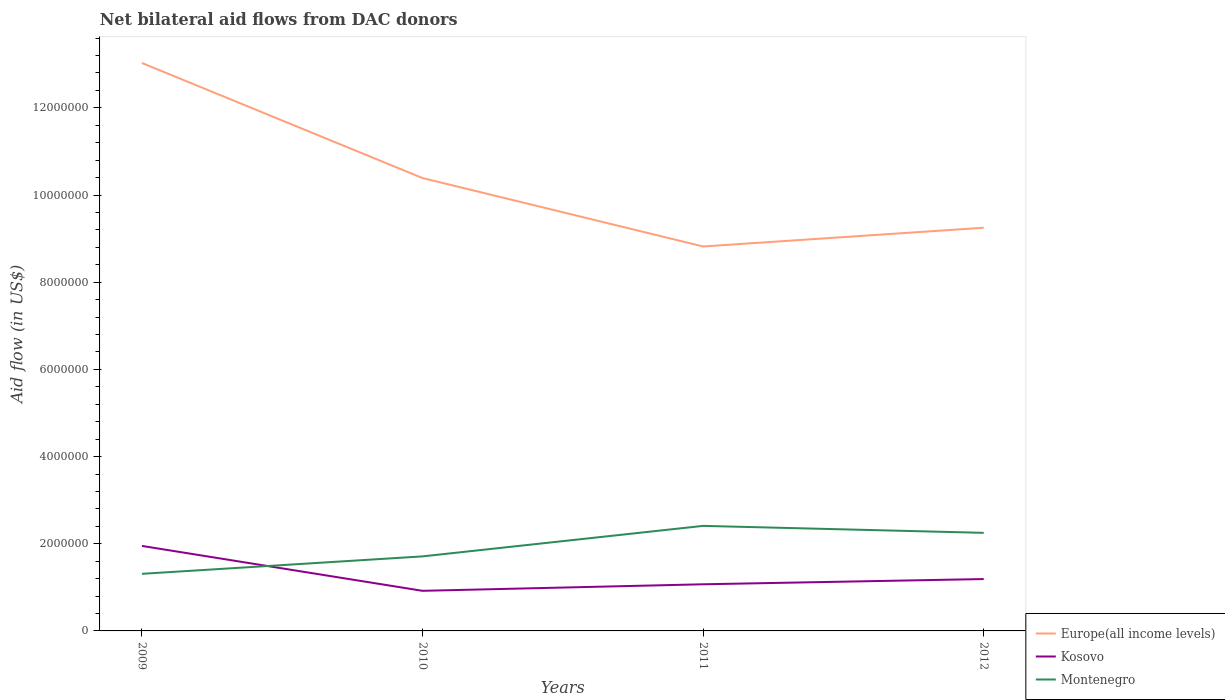Is the number of lines equal to the number of legend labels?
Keep it short and to the point. Yes. Across all years, what is the maximum net bilateral aid flow in Europe(all income levels)?
Give a very brief answer. 8.82e+06. In which year was the net bilateral aid flow in Europe(all income levels) maximum?
Your answer should be very brief. 2011. What is the total net bilateral aid flow in Kosovo in the graph?
Make the answer very short. 8.80e+05. What is the difference between the highest and the second highest net bilateral aid flow in Montenegro?
Offer a very short reply. 1.10e+06. Is the net bilateral aid flow in Kosovo strictly greater than the net bilateral aid flow in Europe(all income levels) over the years?
Your response must be concise. Yes. How many lines are there?
Your answer should be compact. 3. What is the difference between two consecutive major ticks on the Y-axis?
Ensure brevity in your answer.  2.00e+06. Are the values on the major ticks of Y-axis written in scientific E-notation?
Provide a short and direct response. No. Where does the legend appear in the graph?
Offer a very short reply. Bottom right. What is the title of the graph?
Your response must be concise. Net bilateral aid flows from DAC donors. Does "Thailand" appear as one of the legend labels in the graph?
Provide a short and direct response. No. What is the label or title of the X-axis?
Your answer should be very brief. Years. What is the label or title of the Y-axis?
Provide a short and direct response. Aid flow (in US$). What is the Aid flow (in US$) in Europe(all income levels) in 2009?
Offer a terse response. 1.30e+07. What is the Aid flow (in US$) in Kosovo in 2009?
Provide a short and direct response. 1.95e+06. What is the Aid flow (in US$) of Montenegro in 2009?
Ensure brevity in your answer.  1.31e+06. What is the Aid flow (in US$) of Europe(all income levels) in 2010?
Offer a terse response. 1.04e+07. What is the Aid flow (in US$) of Kosovo in 2010?
Your answer should be compact. 9.20e+05. What is the Aid flow (in US$) of Montenegro in 2010?
Your response must be concise. 1.71e+06. What is the Aid flow (in US$) of Europe(all income levels) in 2011?
Provide a succinct answer. 8.82e+06. What is the Aid flow (in US$) in Kosovo in 2011?
Keep it short and to the point. 1.07e+06. What is the Aid flow (in US$) of Montenegro in 2011?
Ensure brevity in your answer.  2.41e+06. What is the Aid flow (in US$) of Europe(all income levels) in 2012?
Ensure brevity in your answer.  9.25e+06. What is the Aid flow (in US$) in Kosovo in 2012?
Your answer should be very brief. 1.19e+06. What is the Aid flow (in US$) of Montenegro in 2012?
Provide a succinct answer. 2.25e+06. Across all years, what is the maximum Aid flow (in US$) of Europe(all income levels)?
Your response must be concise. 1.30e+07. Across all years, what is the maximum Aid flow (in US$) in Kosovo?
Offer a terse response. 1.95e+06. Across all years, what is the maximum Aid flow (in US$) of Montenegro?
Your response must be concise. 2.41e+06. Across all years, what is the minimum Aid flow (in US$) of Europe(all income levels)?
Your answer should be compact. 8.82e+06. Across all years, what is the minimum Aid flow (in US$) of Kosovo?
Your answer should be very brief. 9.20e+05. Across all years, what is the minimum Aid flow (in US$) of Montenegro?
Provide a short and direct response. 1.31e+06. What is the total Aid flow (in US$) of Europe(all income levels) in the graph?
Your response must be concise. 4.15e+07. What is the total Aid flow (in US$) of Kosovo in the graph?
Offer a terse response. 5.13e+06. What is the total Aid flow (in US$) of Montenegro in the graph?
Your response must be concise. 7.68e+06. What is the difference between the Aid flow (in US$) in Europe(all income levels) in 2009 and that in 2010?
Make the answer very short. 2.64e+06. What is the difference between the Aid flow (in US$) in Kosovo in 2009 and that in 2010?
Your answer should be compact. 1.03e+06. What is the difference between the Aid flow (in US$) of Montenegro in 2009 and that in 2010?
Provide a short and direct response. -4.00e+05. What is the difference between the Aid flow (in US$) of Europe(all income levels) in 2009 and that in 2011?
Your answer should be very brief. 4.21e+06. What is the difference between the Aid flow (in US$) in Kosovo in 2009 and that in 2011?
Provide a short and direct response. 8.80e+05. What is the difference between the Aid flow (in US$) of Montenegro in 2009 and that in 2011?
Ensure brevity in your answer.  -1.10e+06. What is the difference between the Aid flow (in US$) in Europe(all income levels) in 2009 and that in 2012?
Offer a terse response. 3.78e+06. What is the difference between the Aid flow (in US$) in Kosovo in 2009 and that in 2012?
Your response must be concise. 7.60e+05. What is the difference between the Aid flow (in US$) of Montenegro in 2009 and that in 2012?
Give a very brief answer. -9.40e+05. What is the difference between the Aid flow (in US$) of Europe(all income levels) in 2010 and that in 2011?
Make the answer very short. 1.57e+06. What is the difference between the Aid flow (in US$) in Montenegro in 2010 and that in 2011?
Give a very brief answer. -7.00e+05. What is the difference between the Aid flow (in US$) in Europe(all income levels) in 2010 and that in 2012?
Keep it short and to the point. 1.14e+06. What is the difference between the Aid flow (in US$) in Kosovo in 2010 and that in 2012?
Provide a succinct answer. -2.70e+05. What is the difference between the Aid flow (in US$) of Montenegro in 2010 and that in 2012?
Provide a succinct answer. -5.40e+05. What is the difference between the Aid flow (in US$) of Europe(all income levels) in 2011 and that in 2012?
Your answer should be compact. -4.30e+05. What is the difference between the Aid flow (in US$) in Montenegro in 2011 and that in 2012?
Make the answer very short. 1.60e+05. What is the difference between the Aid flow (in US$) in Europe(all income levels) in 2009 and the Aid flow (in US$) in Kosovo in 2010?
Offer a very short reply. 1.21e+07. What is the difference between the Aid flow (in US$) of Europe(all income levels) in 2009 and the Aid flow (in US$) of Montenegro in 2010?
Offer a very short reply. 1.13e+07. What is the difference between the Aid flow (in US$) of Europe(all income levels) in 2009 and the Aid flow (in US$) of Kosovo in 2011?
Ensure brevity in your answer.  1.20e+07. What is the difference between the Aid flow (in US$) of Europe(all income levels) in 2009 and the Aid flow (in US$) of Montenegro in 2011?
Ensure brevity in your answer.  1.06e+07. What is the difference between the Aid flow (in US$) of Kosovo in 2009 and the Aid flow (in US$) of Montenegro in 2011?
Your answer should be very brief. -4.60e+05. What is the difference between the Aid flow (in US$) of Europe(all income levels) in 2009 and the Aid flow (in US$) of Kosovo in 2012?
Offer a terse response. 1.18e+07. What is the difference between the Aid flow (in US$) in Europe(all income levels) in 2009 and the Aid flow (in US$) in Montenegro in 2012?
Ensure brevity in your answer.  1.08e+07. What is the difference between the Aid flow (in US$) in Europe(all income levels) in 2010 and the Aid flow (in US$) in Kosovo in 2011?
Your answer should be very brief. 9.32e+06. What is the difference between the Aid flow (in US$) in Europe(all income levels) in 2010 and the Aid flow (in US$) in Montenegro in 2011?
Provide a short and direct response. 7.98e+06. What is the difference between the Aid flow (in US$) of Kosovo in 2010 and the Aid flow (in US$) of Montenegro in 2011?
Keep it short and to the point. -1.49e+06. What is the difference between the Aid flow (in US$) in Europe(all income levels) in 2010 and the Aid flow (in US$) in Kosovo in 2012?
Ensure brevity in your answer.  9.20e+06. What is the difference between the Aid flow (in US$) of Europe(all income levels) in 2010 and the Aid flow (in US$) of Montenegro in 2012?
Your answer should be very brief. 8.14e+06. What is the difference between the Aid flow (in US$) of Kosovo in 2010 and the Aid flow (in US$) of Montenegro in 2012?
Your answer should be very brief. -1.33e+06. What is the difference between the Aid flow (in US$) in Europe(all income levels) in 2011 and the Aid flow (in US$) in Kosovo in 2012?
Your answer should be very brief. 7.63e+06. What is the difference between the Aid flow (in US$) in Europe(all income levels) in 2011 and the Aid flow (in US$) in Montenegro in 2012?
Your response must be concise. 6.57e+06. What is the difference between the Aid flow (in US$) in Kosovo in 2011 and the Aid flow (in US$) in Montenegro in 2012?
Provide a short and direct response. -1.18e+06. What is the average Aid flow (in US$) in Europe(all income levels) per year?
Provide a short and direct response. 1.04e+07. What is the average Aid flow (in US$) of Kosovo per year?
Offer a very short reply. 1.28e+06. What is the average Aid flow (in US$) in Montenegro per year?
Keep it short and to the point. 1.92e+06. In the year 2009, what is the difference between the Aid flow (in US$) in Europe(all income levels) and Aid flow (in US$) in Kosovo?
Your response must be concise. 1.11e+07. In the year 2009, what is the difference between the Aid flow (in US$) of Europe(all income levels) and Aid flow (in US$) of Montenegro?
Offer a very short reply. 1.17e+07. In the year 2009, what is the difference between the Aid flow (in US$) in Kosovo and Aid flow (in US$) in Montenegro?
Your response must be concise. 6.40e+05. In the year 2010, what is the difference between the Aid flow (in US$) in Europe(all income levels) and Aid flow (in US$) in Kosovo?
Your answer should be compact. 9.47e+06. In the year 2010, what is the difference between the Aid flow (in US$) in Europe(all income levels) and Aid flow (in US$) in Montenegro?
Your answer should be compact. 8.68e+06. In the year 2010, what is the difference between the Aid flow (in US$) of Kosovo and Aid flow (in US$) of Montenegro?
Offer a very short reply. -7.90e+05. In the year 2011, what is the difference between the Aid flow (in US$) of Europe(all income levels) and Aid flow (in US$) of Kosovo?
Offer a terse response. 7.75e+06. In the year 2011, what is the difference between the Aid flow (in US$) of Europe(all income levels) and Aid flow (in US$) of Montenegro?
Give a very brief answer. 6.41e+06. In the year 2011, what is the difference between the Aid flow (in US$) in Kosovo and Aid flow (in US$) in Montenegro?
Ensure brevity in your answer.  -1.34e+06. In the year 2012, what is the difference between the Aid flow (in US$) of Europe(all income levels) and Aid flow (in US$) of Kosovo?
Offer a very short reply. 8.06e+06. In the year 2012, what is the difference between the Aid flow (in US$) in Europe(all income levels) and Aid flow (in US$) in Montenegro?
Offer a terse response. 7.00e+06. In the year 2012, what is the difference between the Aid flow (in US$) of Kosovo and Aid flow (in US$) of Montenegro?
Offer a very short reply. -1.06e+06. What is the ratio of the Aid flow (in US$) of Europe(all income levels) in 2009 to that in 2010?
Keep it short and to the point. 1.25. What is the ratio of the Aid flow (in US$) of Kosovo in 2009 to that in 2010?
Ensure brevity in your answer.  2.12. What is the ratio of the Aid flow (in US$) in Montenegro in 2009 to that in 2010?
Ensure brevity in your answer.  0.77. What is the ratio of the Aid flow (in US$) of Europe(all income levels) in 2009 to that in 2011?
Your response must be concise. 1.48. What is the ratio of the Aid flow (in US$) in Kosovo in 2009 to that in 2011?
Your answer should be compact. 1.82. What is the ratio of the Aid flow (in US$) in Montenegro in 2009 to that in 2011?
Your response must be concise. 0.54. What is the ratio of the Aid flow (in US$) of Europe(all income levels) in 2009 to that in 2012?
Provide a succinct answer. 1.41. What is the ratio of the Aid flow (in US$) in Kosovo in 2009 to that in 2012?
Make the answer very short. 1.64. What is the ratio of the Aid flow (in US$) in Montenegro in 2009 to that in 2012?
Provide a succinct answer. 0.58. What is the ratio of the Aid flow (in US$) in Europe(all income levels) in 2010 to that in 2011?
Offer a terse response. 1.18. What is the ratio of the Aid flow (in US$) in Kosovo in 2010 to that in 2011?
Keep it short and to the point. 0.86. What is the ratio of the Aid flow (in US$) in Montenegro in 2010 to that in 2011?
Your answer should be compact. 0.71. What is the ratio of the Aid flow (in US$) in Europe(all income levels) in 2010 to that in 2012?
Offer a terse response. 1.12. What is the ratio of the Aid flow (in US$) of Kosovo in 2010 to that in 2012?
Offer a terse response. 0.77. What is the ratio of the Aid flow (in US$) of Montenegro in 2010 to that in 2012?
Provide a succinct answer. 0.76. What is the ratio of the Aid flow (in US$) in Europe(all income levels) in 2011 to that in 2012?
Your response must be concise. 0.95. What is the ratio of the Aid flow (in US$) of Kosovo in 2011 to that in 2012?
Keep it short and to the point. 0.9. What is the ratio of the Aid flow (in US$) of Montenegro in 2011 to that in 2012?
Ensure brevity in your answer.  1.07. What is the difference between the highest and the second highest Aid flow (in US$) of Europe(all income levels)?
Make the answer very short. 2.64e+06. What is the difference between the highest and the second highest Aid flow (in US$) of Kosovo?
Give a very brief answer. 7.60e+05. What is the difference between the highest and the second highest Aid flow (in US$) in Montenegro?
Give a very brief answer. 1.60e+05. What is the difference between the highest and the lowest Aid flow (in US$) of Europe(all income levels)?
Ensure brevity in your answer.  4.21e+06. What is the difference between the highest and the lowest Aid flow (in US$) of Kosovo?
Offer a very short reply. 1.03e+06. What is the difference between the highest and the lowest Aid flow (in US$) in Montenegro?
Offer a very short reply. 1.10e+06. 